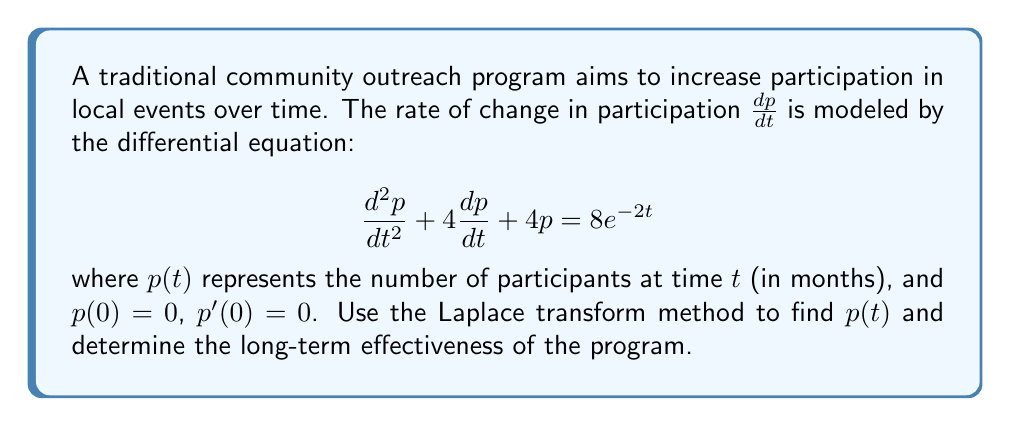Solve this math problem. To solve this problem using the Laplace transform method, we'll follow these steps:

1) Take the Laplace transform of both sides of the differential equation:

   $\mathcal{L}\{p''(t) + 4p'(t) + 4p(t)\} = \mathcal{L}\{8e^{-2t}\}$

2) Use the properties of Laplace transforms:

   $s^2P(s) - sp(0) - p'(0) + 4[sP(s) - p(0)] + 4P(s) = \frac{8}{s+2}$

   Where $P(s) = \mathcal{L}\{p(t)\}$

3) Substitute the initial conditions $p(0) = 0$ and $p'(0) = 0$:

   $s^2P(s) + 4sP(s) + 4P(s) = \frac{8}{s+2}$

4) Factor out $P(s)$:

   $P(s)(s^2 + 4s + 4) = \frac{8}{s+2}$

5) Solve for $P(s)$:

   $P(s) = \frac{8}{(s+2)(s^2 + 4s + 4)} = \frac{8}{(s+2)^3}$

6) Perform partial fraction decomposition:

   $P(s) = \frac{A}{s+2} + \frac{B}{(s+2)^2} + \frac{C}{(s+2)^3}$

   where $A = 1$, $B = 2$, and $C = 1$

7) Take the inverse Laplace transform:

   $p(t) = \mathcal{L}^{-1}\{P(s)\} = e^{-2t} + 2te^{-2t} + \frac{1}{2}t^2e^{-2t}$

8) To determine the long-term effectiveness, we can find the limit as $t$ approaches infinity:

   $\lim_{t \to \infty} p(t) = \lim_{t \to \infty} (e^{-2t} + 2te^{-2t} + \frac{1}{2}t^2e^{-2t}) = 0$

This indicates that the participation will eventually decay to zero, suggesting that the program's effectiveness diminishes over time.
Answer: $p(t) = e^{-2t} + 2te^{-2t} + \frac{1}{2}t^2e^{-2t}$

The long-term effectiveness approaches zero, indicating that the traditional outreach program's impact diminishes over time. 